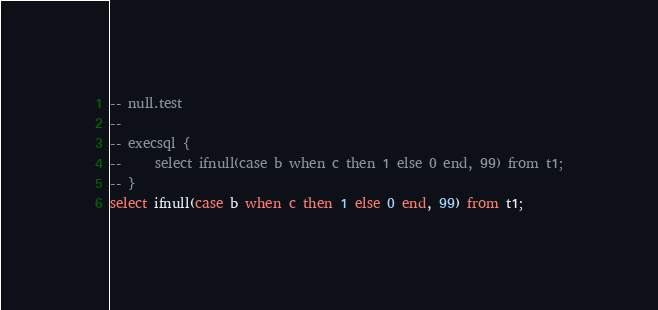Convert code to text. <code><loc_0><loc_0><loc_500><loc_500><_SQL_>-- null.test
-- 
-- execsql {
--     select ifnull(case b when c then 1 else 0 end, 99) from t1;
-- }
select ifnull(case b when c then 1 else 0 end, 99) from t1;</code> 